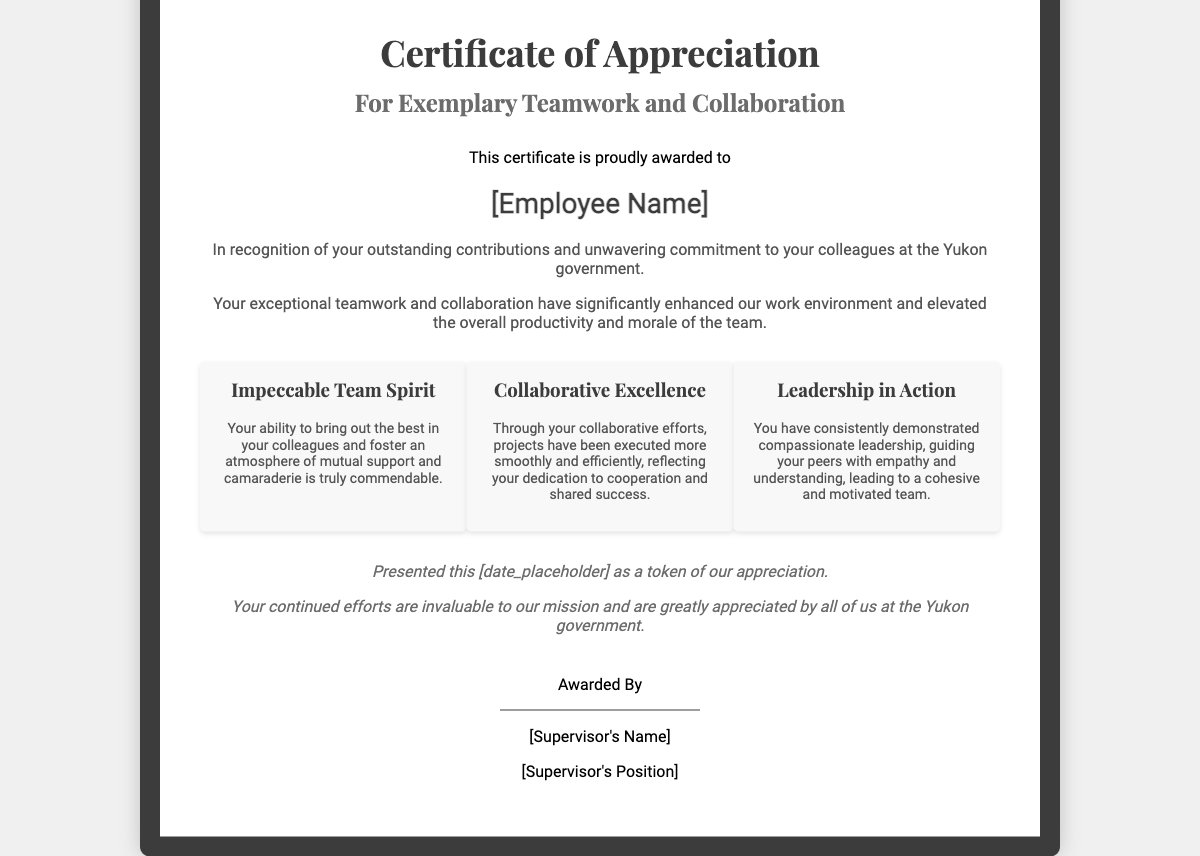What is the title of the certificate? The title of the certificate is prominently displayed at the top of the document, which reads "Certificate of Appreciation."
Answer: Certificate of Appreciation Who is the certificate awarded to? The recipient's name is highlighted in a distinct section where it states, "This certificate is proudly awarded to," followed by [Employee Name].
Answer: [Employee Name] What is the date of presentation? The date of presentation is indicated with a placeholder in the text stating, "Presented this [date_placeholder]."
Answer: [date_placeholder] What position does the awarder hold? The position of the person awarding the certificate is noted in the signature section, where it mentions "[Supervisor's Position]."
Answer: [Supervisor's Position] What are the key attributes recognized in this certificate? The certificate highlights three specific attributes: "Impeccable Team Spirit," "Collaborative Excellence," and "Leadership in Action."
Answer: Impeccable Team Spirit, Collaborative Excellence, Leadership in Action What color is the background of the certificate? The background color of the certificate is specified in the styling section, and the document clearly represents it, which is white.
Answer: White What is a primary reason for the award? The certificate states that it is in recognition of outstanding contributions and unwavering commitment to colleagues.
Answer: Outstanding contributions What tone does the closing notes of the certificate take? The closing notes express a tone of gratitude and encouragement regarding the recipient's efforts, stating they are "invaluable" and "greatly appreciated."
Answer: Gratitude and encouragement Who signs the certificate? The signature section indicates that the certificate is awarded by an individual, referred to as "[Supervisor's Name]."
Answer: [Supervisor's Name] 